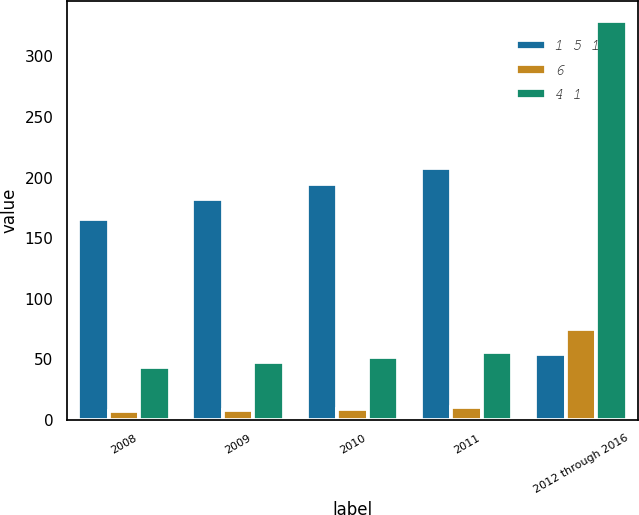Convert chart to OTSL. <chart><loc_0><loc_0><loc_500><loc_500><stacked_bar_chart><ecel><fcel>2008<fcel>2009<fcel>2010<fcel>2011<fcel>2012 through 2016<nl><fcel>1 5 1<fcel>166<fcel>182<fcel>195<fcel>208<fcel>54<nl><fcel>6<fcel>7<fcel>8<fcel>9<fcel>11<fcel>75<nl><fcel>4 1<fcel>44<fcel>48<fcel>52<fcel>56<fcel>329<nl></chart> 